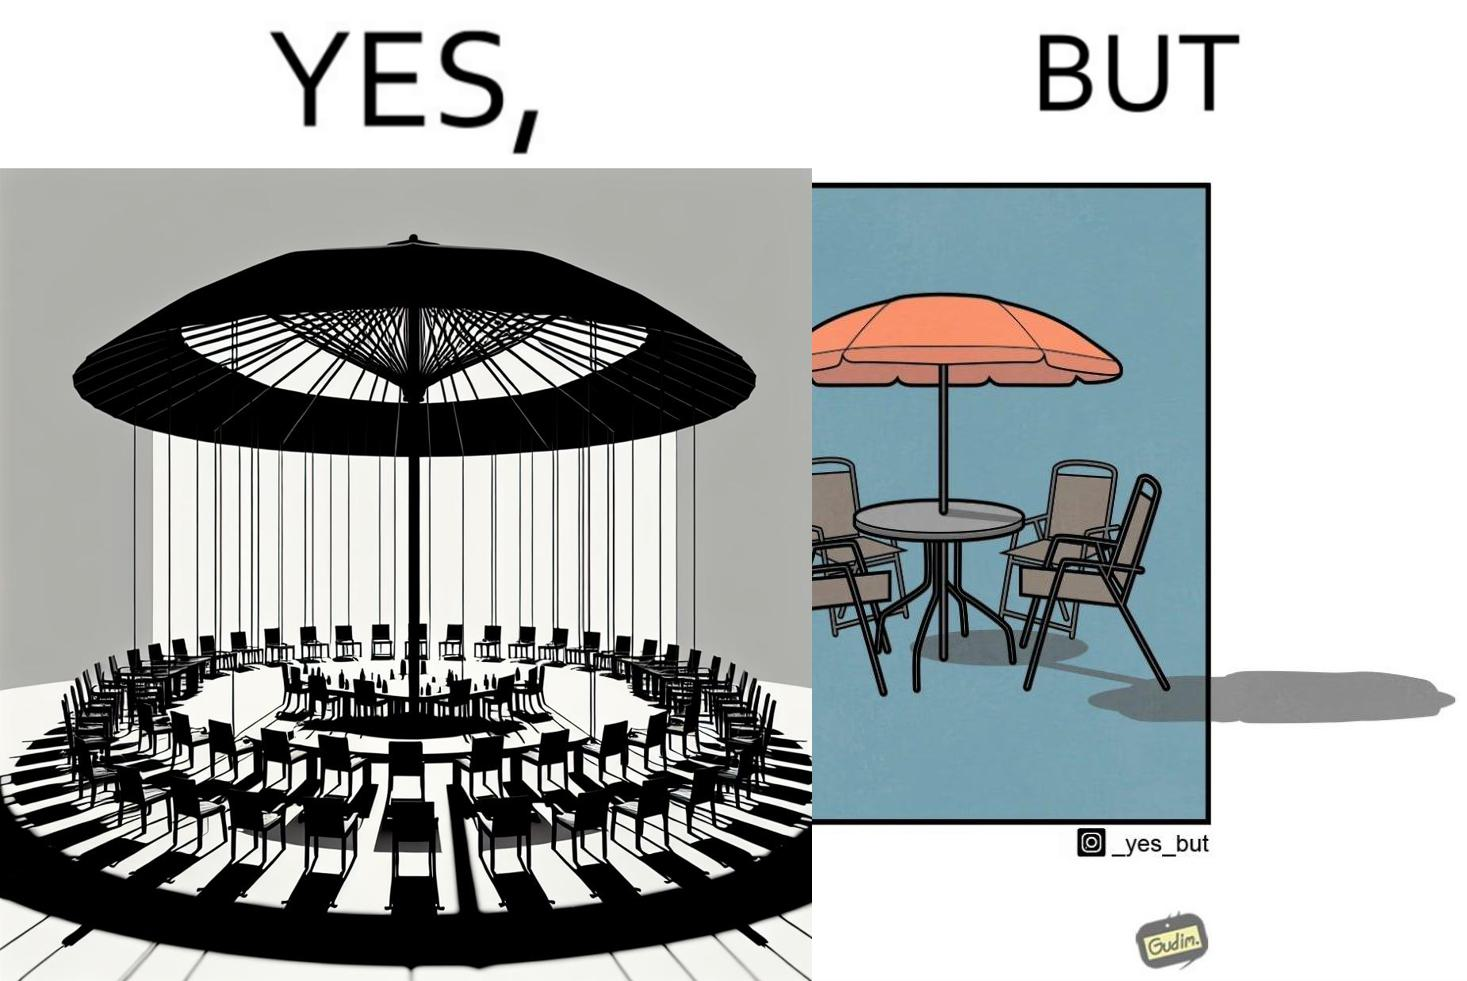Is this a satirical image? Yes, this image is satirical. 